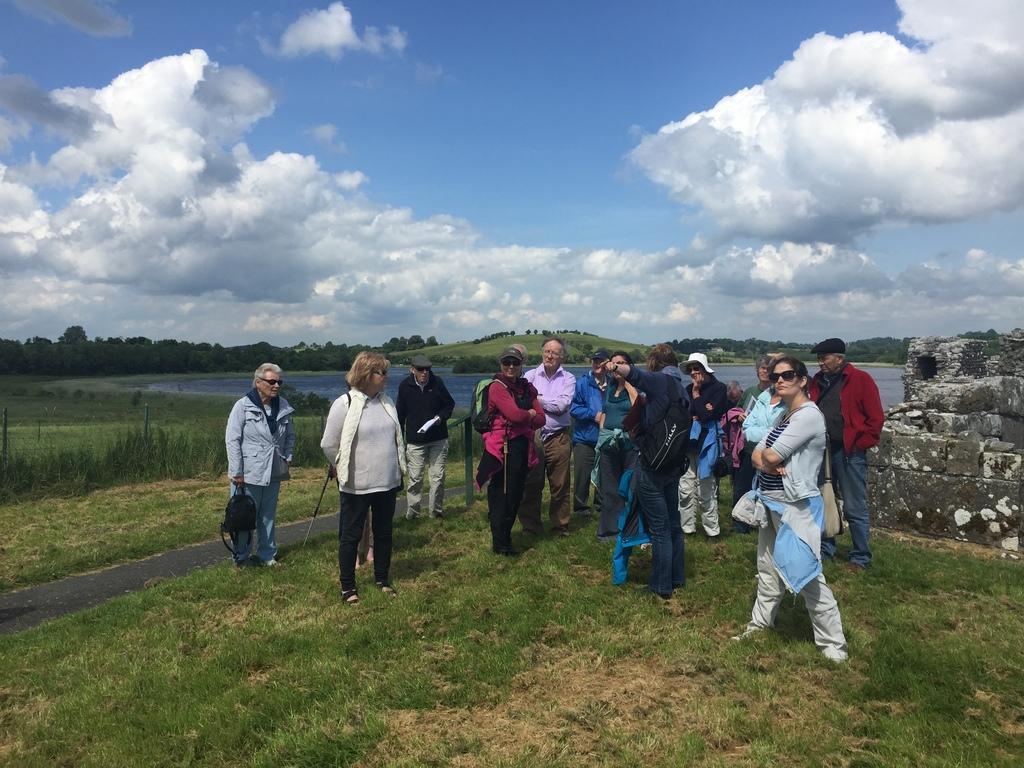Can you describe this image briefly? In the picture we can see a few people are standing on the grass surface and beside them, we can see a part of the wall and in the background, we can see the water surface, trees, hill covered with grass and behind it we can see the sky with clouds. 